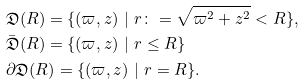Convert formula to latex. <formula><loc_0><loc_0><loc_500><loc_500>& \mathfrak { D } ( R ) = \{ ( \varpi , z ) \ | \ r \colon = \sqrt { \varpi ^ { 2 } + z ^ { 2 } } < R \} , \\ & \bar { \mathfrak { D } } ( R ) = \{ ( \varpi , z ) \ | \ r \leq R \} \\ & \partial \mathfrak { D } ( R ) = \{ ( \varpi , z ) \ | \ r = R \} .</formula> 